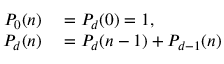Convert formula to latex. <formula><loc_0><loc_0><loc_500><loc_500>\begin{array} { r l } { P _ { 0 } ( n ) } & = P _ { d } ( 0 ) = 1 , } \\ { P _ { d } ( n ) } & = P _ { d } ( n - 1 ) + P _ { d - 1 } ( n ) } \end{array}</formula> 